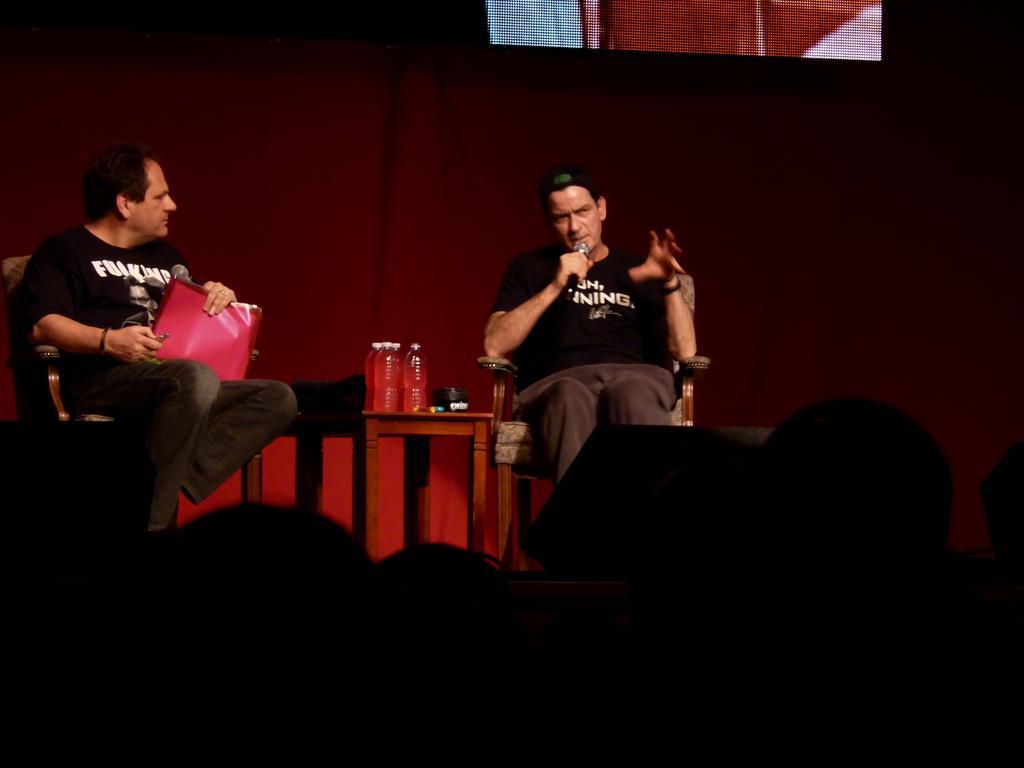In one or two sentences, can you explain what this image depicts? At the bottom of the image there are few people. In front of the people there are two men sitting on the stage. At the right side of the image there is a man sitting and talking. In between them there is a table with bottles. There is a red color background. 